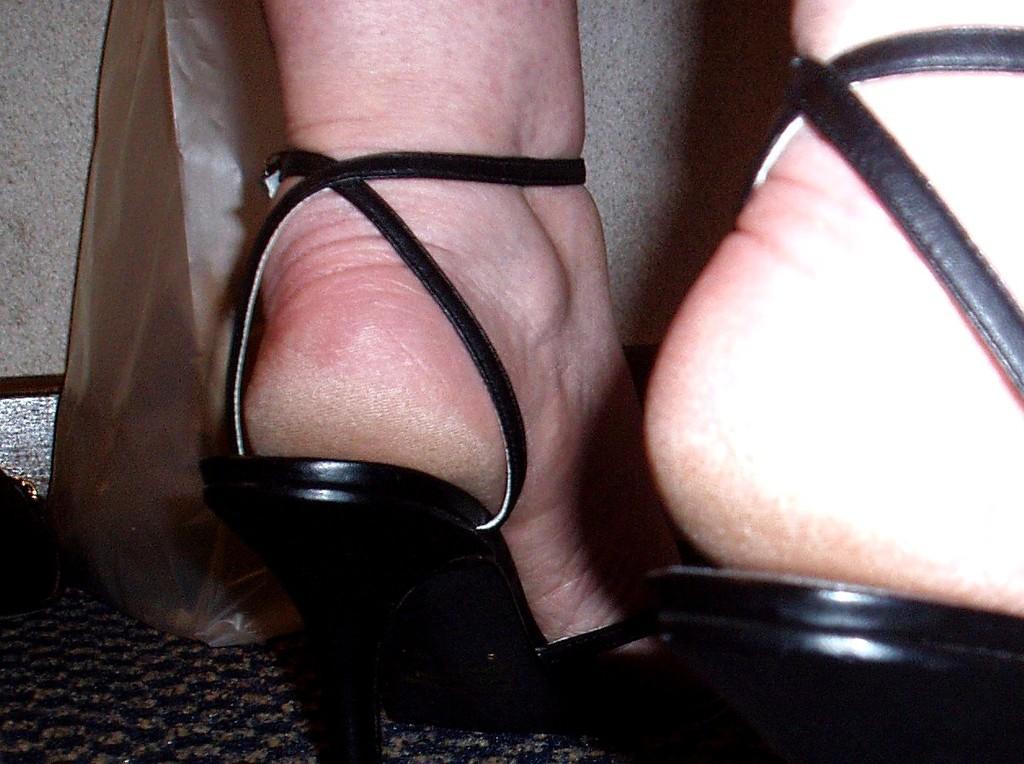Describe this image in one or two sentences. In this image I can see a person's legs and a bag on the floor. This image is taken may be in a room. 